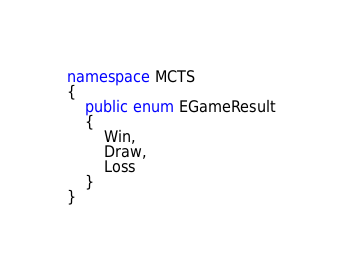Convert code to text. <code><loc_0><loc_0><loc_500><loc_500><_C#_>
namespace MCTS
{
    public enum EGameResult
    {
        Win, 
        Draw,
        Loss
    }
}   
</code> 